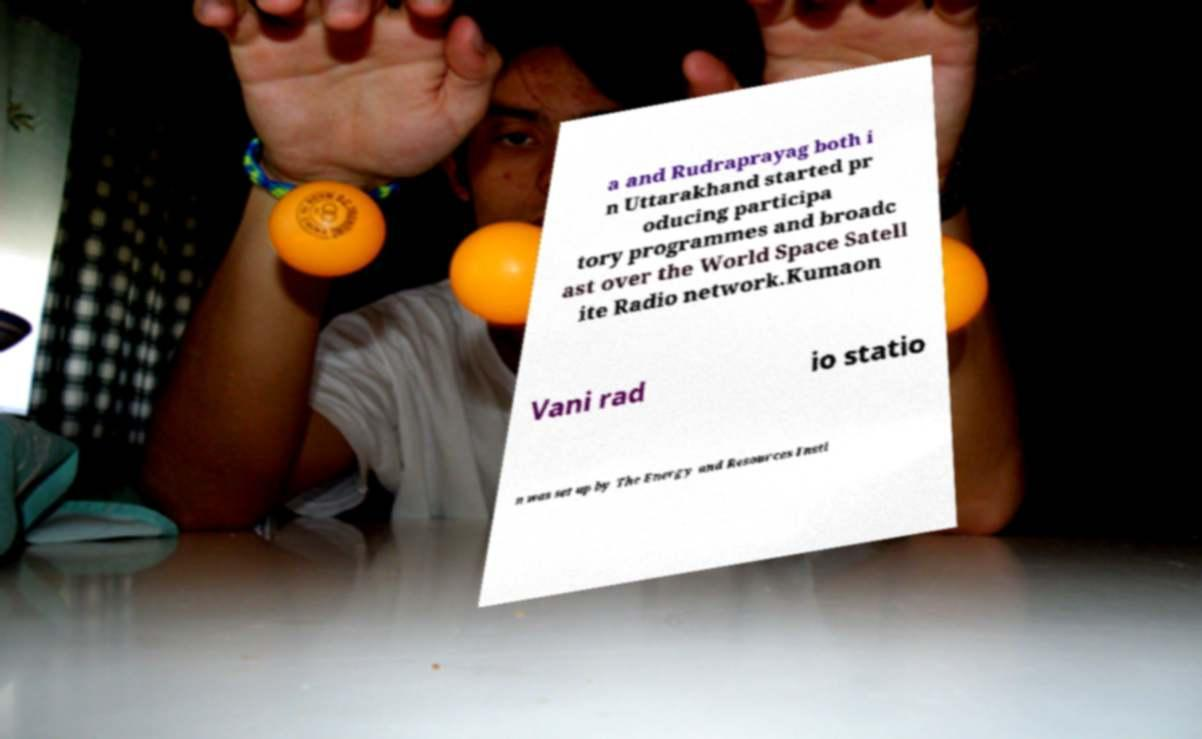Can you read and provide the text displayed in the image?This photo seems to have some interesting text. Can you extract and type it out for me? a and Rudraprayag both i n Uttarakhand started pr oducing participa tory programmes and broadc ast over the World Space Satell ite Radio network.Kumaon Vani rad io statio n was set up by The Energy and Resources Insti 